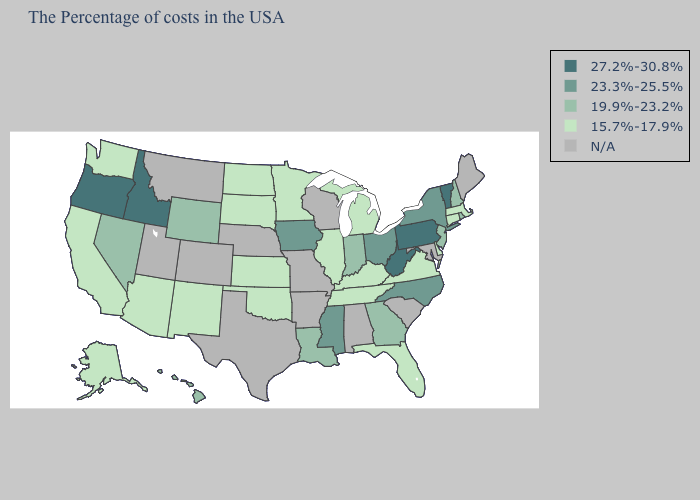What is the value of Massachusetts?
Be succinct. 15.7%-17.9%. Does Illinois have the lowest value in the MidWest?
Keep it brief. Yes. Name the states that have a value in the range 19.9%-23.2%?
Answer briefly. Rhode Island, New Hampshire, New Jersey, Georgia, Indiana, Louisiana, Wyoming, Nevada, Hawaii. What is the highest value in the Northeast ?
Write a very short answer. 27.2%-30.8%. Does Pennsylvania have the highest value in the USA?
Keep it brief. Yes. Which states have the lowest value in the USA?
Answer briefly. Massachusetts, Connecticut, Delaware, Virginia, Florida, Michigan, Kentucky, Tennessee, Illinois, Minnesota, Kansas, Oklahoma, South Dakota, North Dakota, New Mexico, Arizona, California, Washington, Alaska. Does Virginia have the highest value in the South?
Write a very short answer. No. What is the highest value in the USA?
Write a very short answer. 27.2%-30.8%. Which states have the lowest value in the West?
Concise answer only. New Mexico, Arizona, California, Washington, Alaska. What is the highest value in the South ?
Write a very short answer. 27.2%-30.8%. Does the first symbol in the legend represent the smallest category?
Concise answer only. No. Name the states that have a value in the range 23.3%-25.5%?
Answer briefly. New York, North Carolina, Ohio, Mississippi, Iowa. Name the states that have a value in the range N/A?
Be succinct. Maine, Maryland, South Carolina, Alabama, Wisconsin, Missouri, Arkansas, Nebraska, Texas, Colorado, Utah, Montana. What is the value of Minnesota?
Quick response, please. 15.7%-17.9%. 